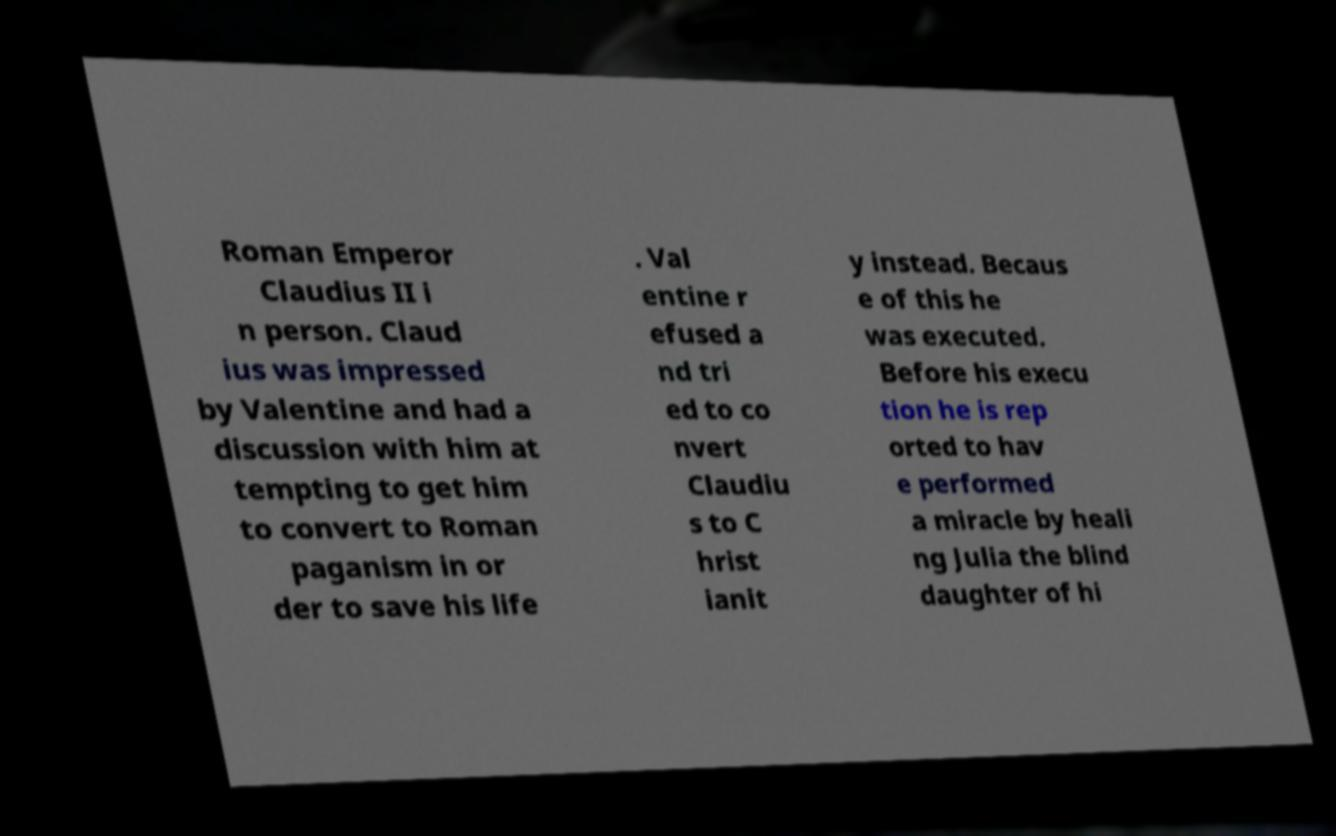Please read and relay the text visible in this image. What does it say? Roman Emperor Claudius II i n person. Claud ius was impressed by Valentine and had a discussion with him at tempting to get him to convert to Roman paganism in or der to save his life . Val entine r efused a nd tri ed to co nvert Claudiu s to C hrist ianit y instead. Becaus e of this he was executed. Before his execu tion he is rep orted to hav e performed a miracle by heali ng Julia the blind daughter of hi 